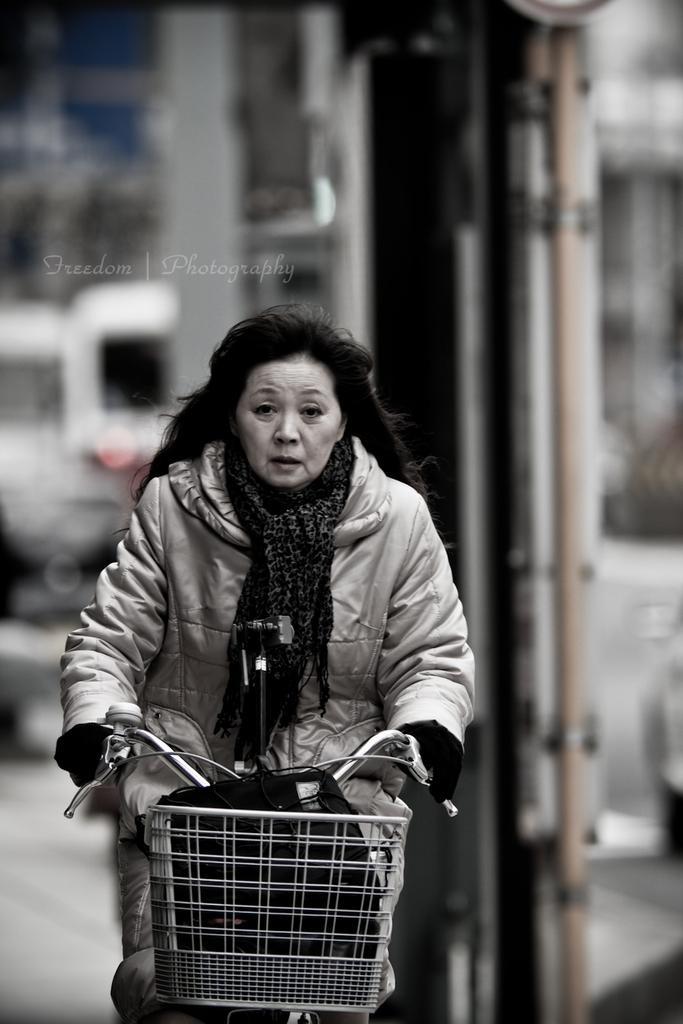Can you describe this image briefly? In this picture I can observe a woman cycling a bicycle in the middle of the picture. The background is completely blurred. This is a black and white image. 